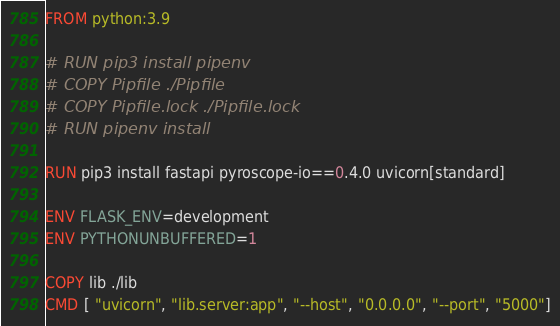Convert code to text. <code><loc_0><loc_0><loc_500><loc_500><_Dockerfile_>FROM python:3.9

# RUN pip3 install pipenv
# COPY Pipfile ./Pipfile
# COPY Pipfile.lock ./Pipfile.lock
# RUN pipenv install

RUN pip3 install fastapi pyroscope-io==0.4.0 uvicorn[standard]

ENV FLASK_ENV=development
ENV PYTHONUNBUFFERED=1

COPY lib ./lib
CMD [ "uvicorn", "lib.server:app", "--host", "0.0.0.0", "--port", "5000"]

</code> 